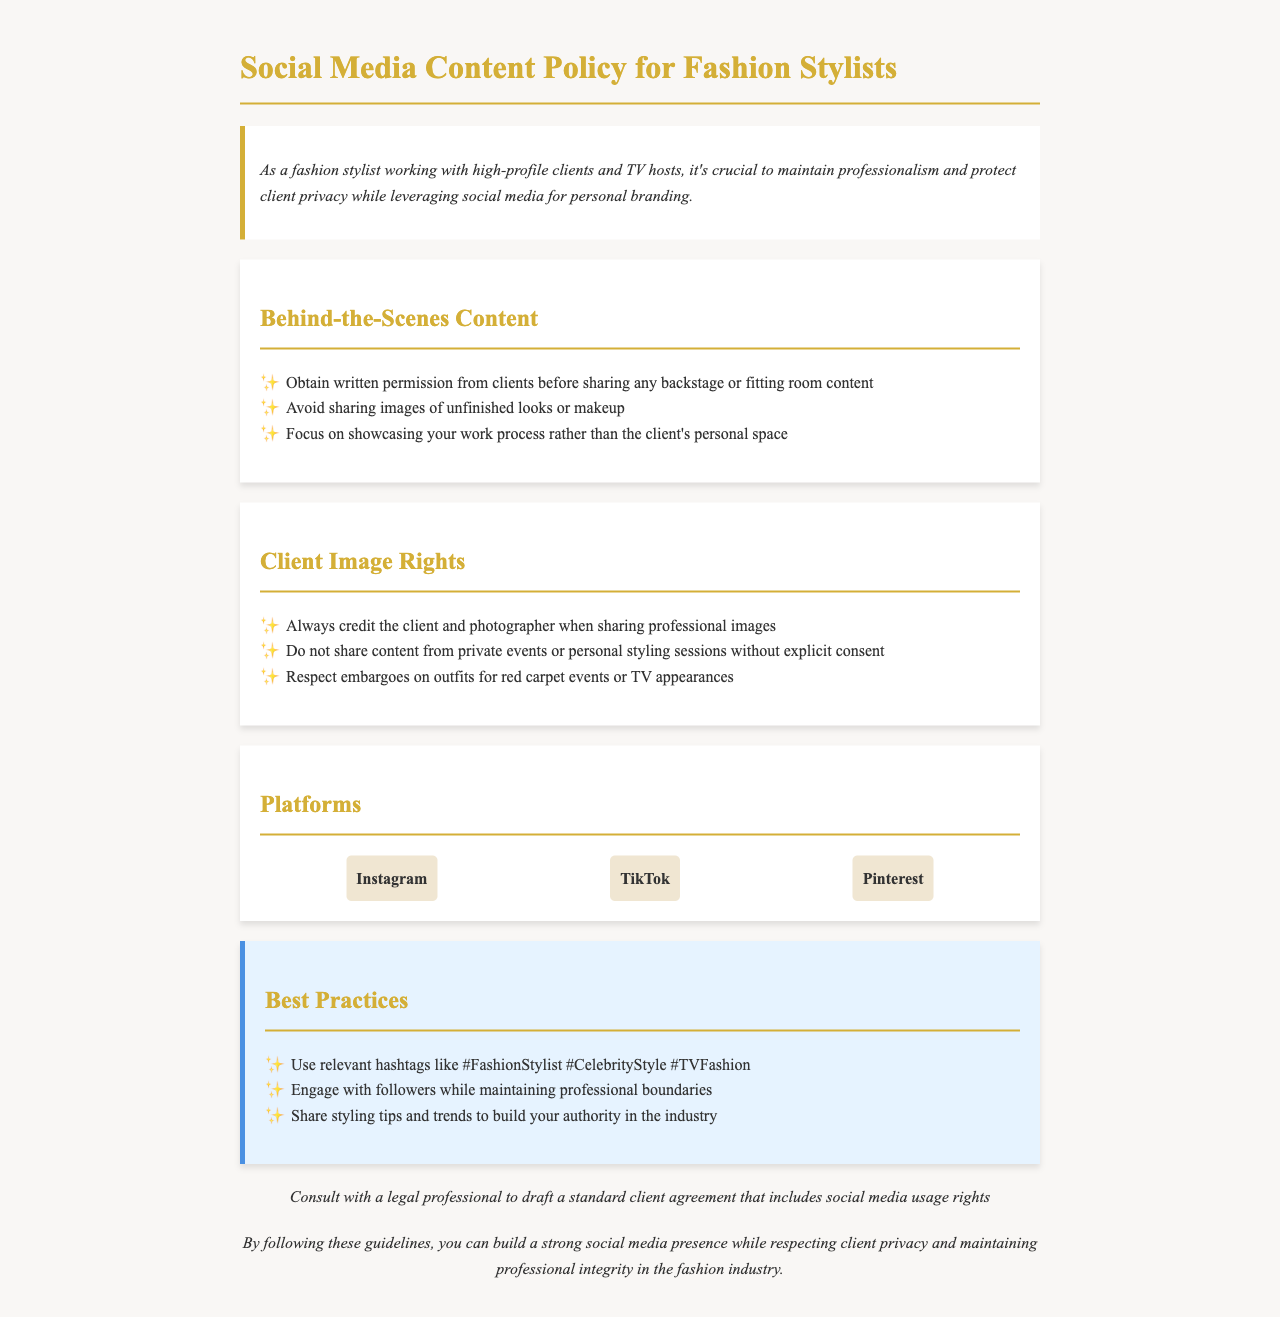What should you obtain before sharing backstage content? The document states you should obtain written permission from clients before sharing any backstage or fitting room content.
Answer: Written permission Which platforms are mentioned in the document? The platforms listed in the document are provided under the section about platforms and include Instagram, TikTok, and Pinterest.
Answer: Instagram, TikTok, Pinterest What is emphasized in the best practices for engaging with followers? The document emphasizes maintaining professional boundaries while engaging with followers.
Answer: Professional boundaries What should you do if you want to share images from a personal styling session? According to the document, you should not share content from private events or personal styling sessions without explicit consent.
Answer: Explicit consent What does the document suggest to build your authority in the industry? The document suggests sharing styling tips and trends as a way to build authority in the industry.
Answer: Styling tips and trends What should you consult a legal professional for? The document advises consulting a legal professional to draft a standard client agreement that includes social media usage rights.
Answer: Standard client agreement What should you respect regarding red carpet events? The document states you should respect embargoes on outfits for red carpet events or TV appearances.
Answer: Embargoes What type of content should be avoided when sharing behind-the-scenes? The document advises avoiding sharing images of unfinished looks or makeup when sharing behind-the-scenes content.
Answer: Unfinished looks or makeup 